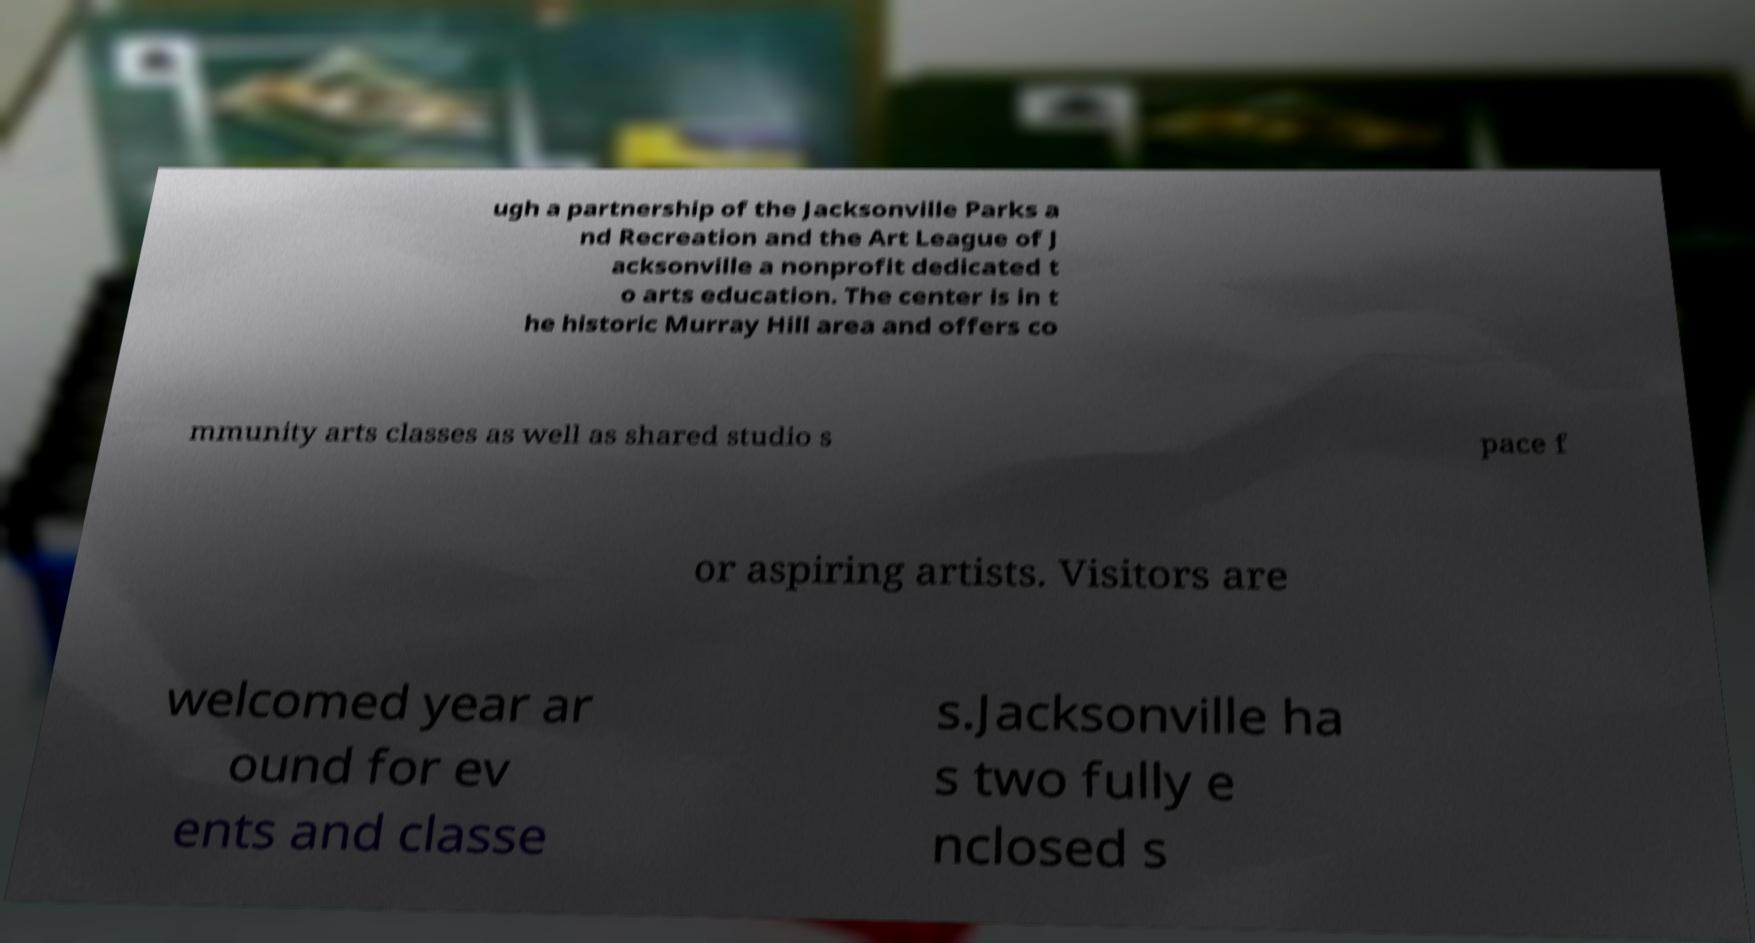Can you accurately transcribe the text from the provided image for me? ugh a partnership of the Jacksonville Parks a nd Recreation and the Art League of J acksonville a nonprofit dedicated t o arts education. The center is in t he historic Murray Hill area and offers co mmunity arts classes as well as shared studio s pace f or aspiring artists. Visitors are welcomed year ar ound for ev ents and classe s.Jacksonville ha s two fully e nclosed s 